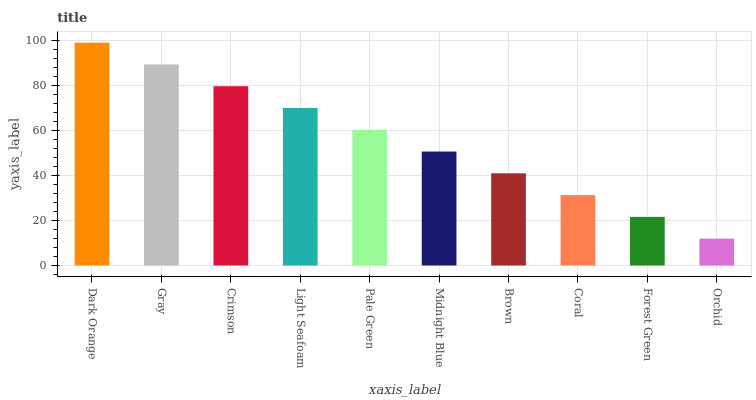Is Orchid the minimum?
Answer yes or no. Yes. Is Dark Orange the maximum?
Answer yes or no. Yes. Is Gray the minimum?
Answer yes or no. No. Is Gray the maximum?
Answer yes or no. No. Is Dark Orange greater than Gray?
Answer yes or no. Yes. Is Gray less than Dark Orange?
Answer yes or no. Yes. Is Gray greater than Dark Orange?
Answer yes or no. No. Is Dark Orange less than Gray?
Answer yes or no. No. Is Pale Green the high median?
Answer yes or no. Yes. Is Midnight Blue the low median?
Answer yes or no. Yes. Is Crimson the high median?
Answer yes or no. No. Is Gray the low median?
Answer yes or no. No. 